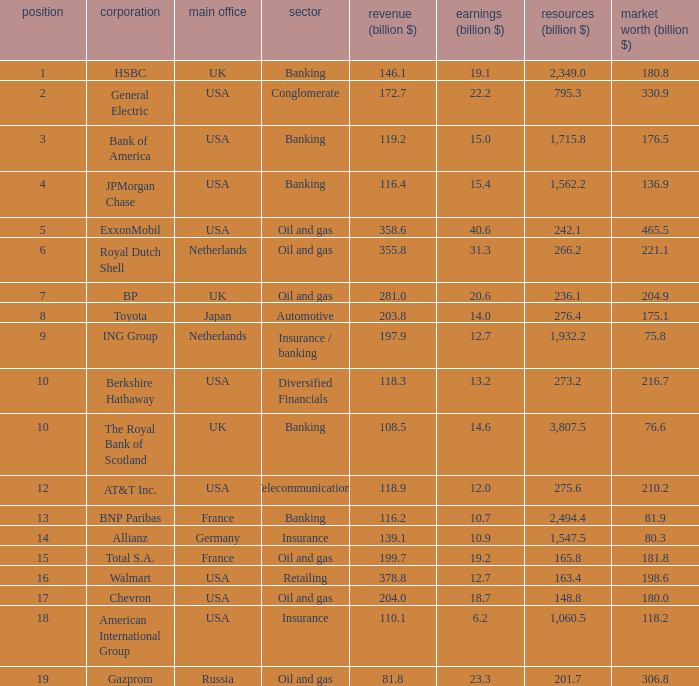What are the profits in billions for Berkshire Hathaway?  13.2. 